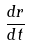<formula> <loc_0><loc_0><loc_500><loc_500>\frac { d r } { d t }</formula> 